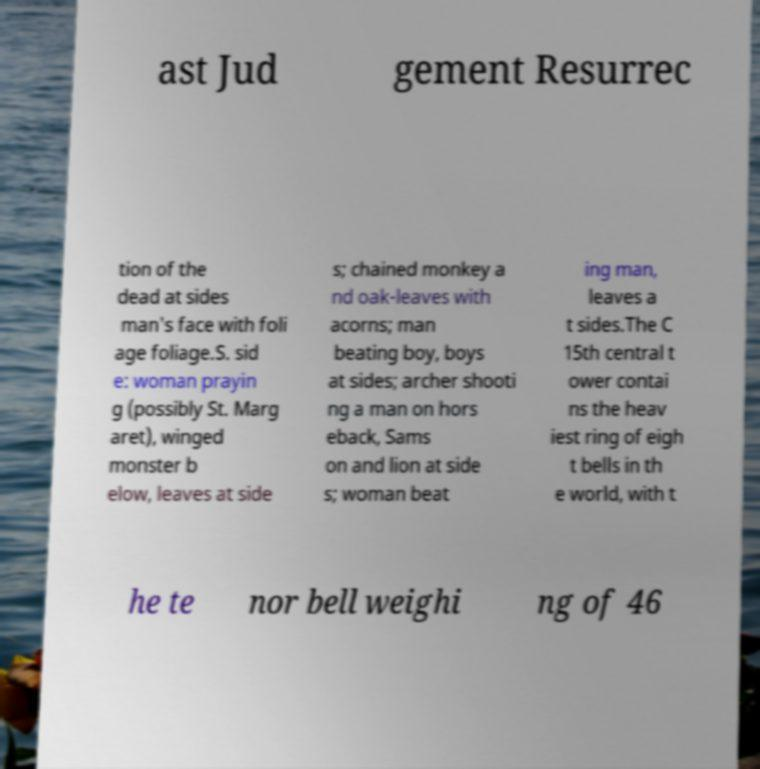Can you accurately transcribe the text from the provided image for me? ast Jud gement Resurrec tion of the dead at sides man's face with foli age foliage.S. sid e: woman prayin g (possibly St. Marg aret), winged monster b elow, leaves at side s; chained monkey a nd oak-leaves with acorns; man beating boy, boys at sides; archer shooti ng a man on hors eback, Sams on and lion at side s; woman beat ing man, leaves a t sides.The C 15th central t ower contai ns the heav iest ring of eigh t bells in th e world, with t he te nor bell weighi ng of 46 